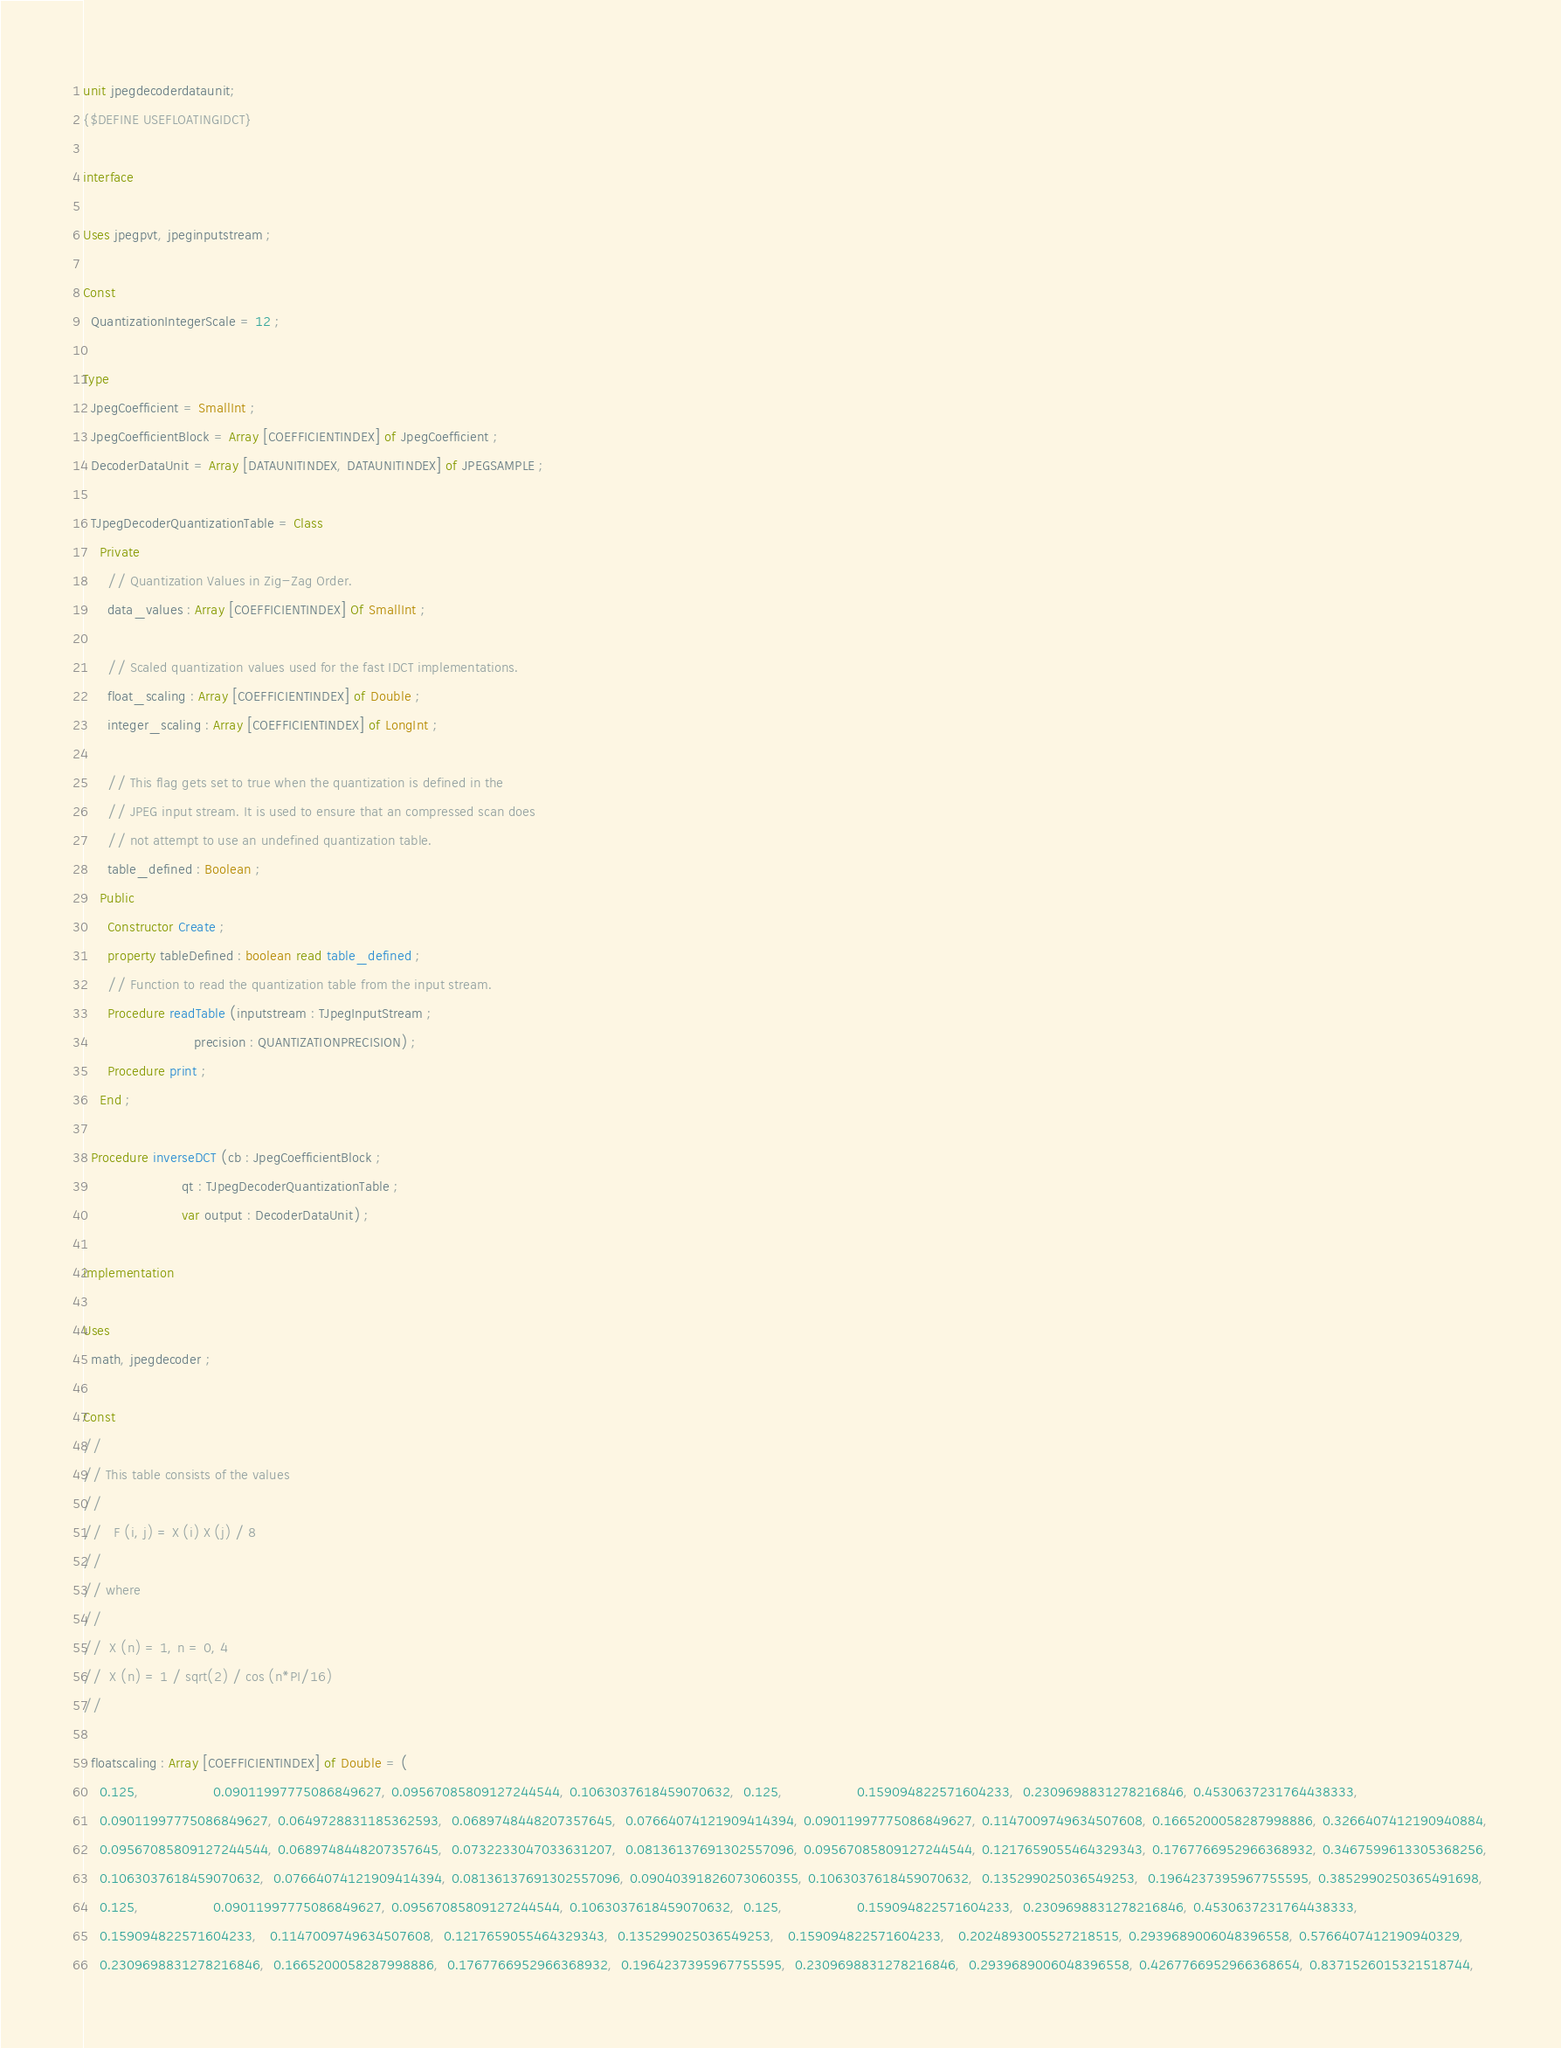Convert code to text. <code><loc_0><loc_0><loc_500><loc_500><_Pascal_>unit jpegdecoderdataunit;
{$DEFINE USEFLOATINGIDCT}

interface

Uses jpegpvt, jpeginputstream ;

Const
  QuantizationIntegerScale = 12 ;

Type
  JpegCoefficient = SmallInt ;
  JpegCoefficientBlock = Array [COEFFICIENTINDEX] of JpegCoefficient ;
  DecoderDataUnit = Array [DATAUNITINDEX, DATAUNITINDEX] of JPEGSAMPLE ;

  TJpegDecoderQuantizationTable = Class
    Private
      // Quantization Values in Zig-Zag Order.
      data_values : Array [COEFFICIENTINDEX] Of SmallInt ;

      // Scaled quantization values used for the fast IDCT implementations.
      float_scaling : Array [COEFFICIENTINDEX] of Double ;
      integer_scaling : Array [COEFFICIENTINDEX] of LongInt ;

      // This flag gets set to true when the quantization is defined in the
      // JPEG input stream. It is used to ensure that an compressed scan does
      // not attempt to use an undefined quantization table.
      table_defined : Boolean ;
    Public
      Constructor Create ;
      property tableDefined : boolean read table_defined ;
      // Function to read the quantization table from the input stream.
      Procedure readTable (inputstream : TJpegInputStream ;
                           precision : QUANTIZATIONPRECISION) ;
      Procedure print ;
    End ;

  Procedure inverseDCT (cb : JpegCoefficientBlock ;
                        qt : TJpegDecoderQuantizationTable ;
                        var output : DecoderDataUnit) ;

implementation

Uses
  math, jpegdecoder ;

Const
//
// This table consists of the values
//
//   F (i, j) = X (i) X (j) / 8
//
// where
//
//  X (n) = 1, n = 0, 4
//  X (n) = 1 / sqrt(2) / cos (n*PI/16)
//

  floatscaling : Array [COEFFICIENTINDEX] of Double = (
    0.125,                  0.09011997775086849627, 0.09567085809127244544, 0.1063037618459070632,  0.125,                  0.159094822571604233,  0.2309698831278216846, 0.4530637231764438333,
    0.09011997775086849627, 0.0649728831185362593,  0.0689748448207357645,  0.07664074121909414394, 0.09011997775086849627, 0.1147009749634507608, 0.1665200058287998886, 0.3266407412190940884,
    0.09567085809127244544, 0.0689748448207357645,  0.0732233047033631207,  0.08136137691302557096, 0.09567085809127244544, 0.1217659055464329343, 0.1767766952966368932, 0.3467599613305368256,
    0.1063037618459070632,  0.07664074121909414394, 0.08136137691302557096, 0.09040391826073060355, 0.1063037618459070632,  0.135299025036549253,  0.1964237395967755595, 0.3852990250365491698,
    0.125,                  0.09011997775086849627, 0.09567085809127244544, 0.1063037618459070632,  0.125,                  0.159094822571604233,  0.2309698831278216846, 0.4530637231764438333,
    0.159094822571604233,   0.1147009749634507608,  0.1217659055464329343,  0.135299025036549253,   0.159094822571604233,   0.2024893005527218515, 0.2939689006048396558, 0.5766407412190940329,
    0.2309698831278216846,  0.1665200058287998886,  0.1767766952966368932,  0.1964237395967755595,  0.2309698831278216846,  0.2939689006048396558, 0.4267766952966368654, 0.8371526015321518744,</code> 